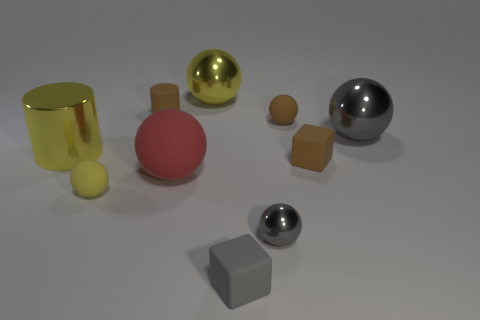Which objects stand out the most due to their size? The large gold ball and the matte red sphere are the most prominent objects in terms of size. They draw the eye due to their volume and central positioning in the composition. 